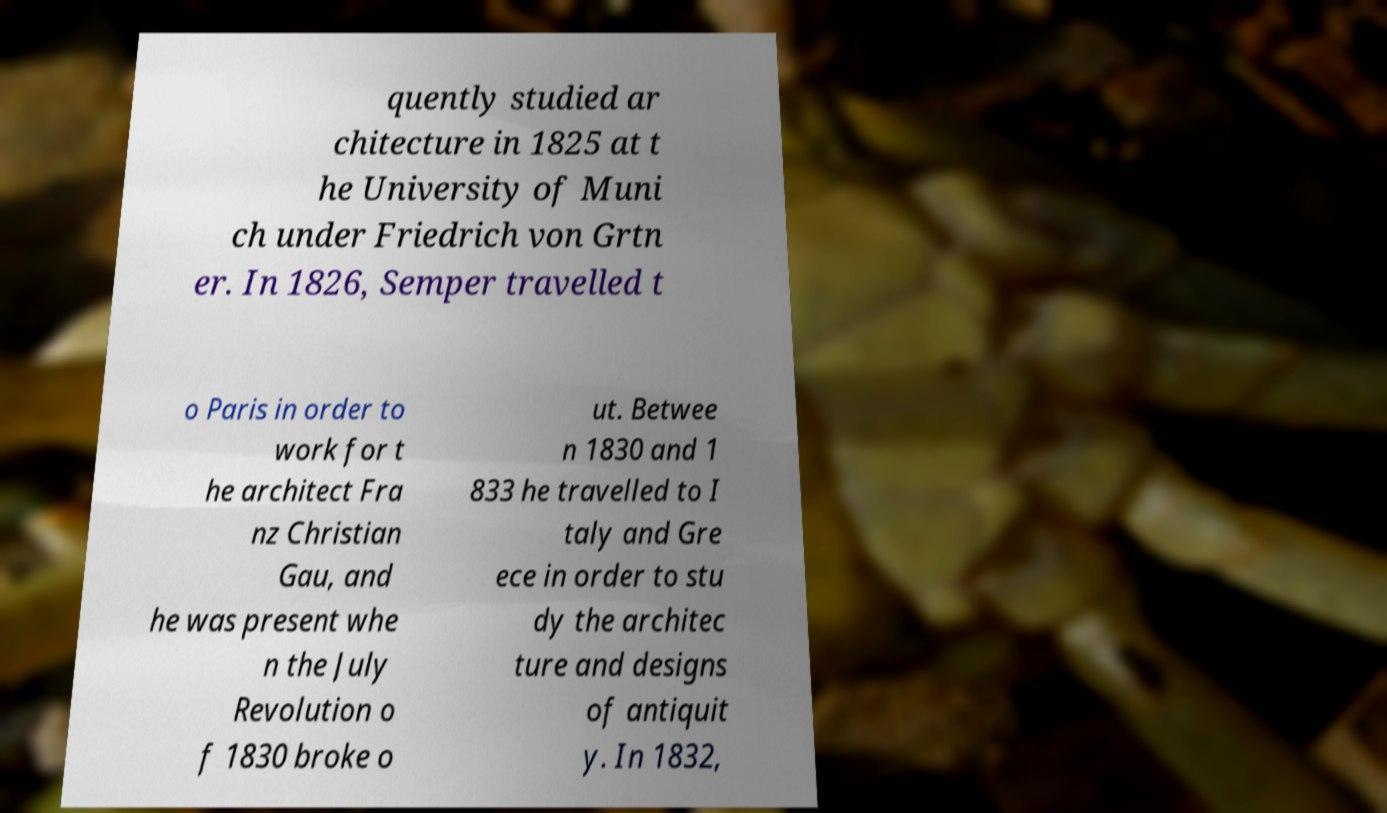Could you extract and type out the text from this image? quently studied ar chitecture in 1825 at t he University of Muni ch under Friedrich von Grtn er. In 1826, Semper travelled t o Paris in order to work for t he architect Fra nz Christian Gau, and he was present whe n the July Revolution o f 1830 broke o ut. Betwee n 1830 and 1 833 he travelled to I taly and Gre ece in order to stu dy the architec ture and designs of antiquit y. In 1832, 